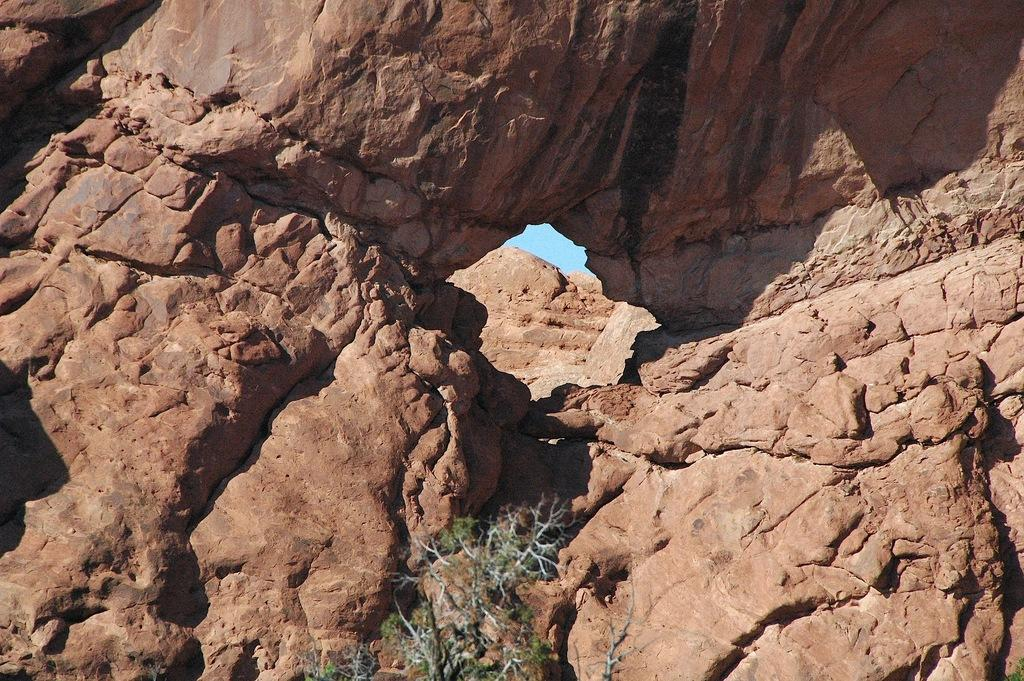What type of natural elements can be seen in the image? There are rocks in the image. Where are the rocks located in the image? The rocks are in the background of the image. What else can be seen in the background of the image? The sky is visible in the background of the image. What type of vegetation is present at the bottom of the image? There is a plant at the bottom of the image. What type of art can be seen on the edge of the rocks in the image? There is no art or edge present on the rocks in the image; they are natural elements. What scientific discoveries can be made by studying the rocks in the image? The image does not provide enough information to make scientific discoveries about the rocks; it only shows their appearance. 